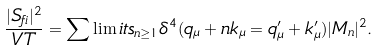<formula> <loc_0><loc_0><loc_500><loc_500>\frac { | S _ { f i } | ^ { 2 } } { V T } = \sum \lim i t s _ { n \geq 1 } \delta ^ { 4 } ( q _ { \mu } + n k _ { \mu } = q ^ { \prime } _ { \mu } + k ^ { \prime } _ { \mu } ) | M _ { n } | ^ { 2 } .</formula> 